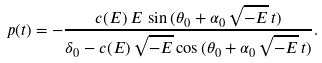Convert formula to latex. <formula><loc_0><loc_0><loc_500><loc_500>p ( t ) = - \frac { c ( E ) \, E \, \sin { ( \theta _ { 0 } + \alpha _ { 0 } \, \sqrt { - E } \, t ) } } { \delta _ { 0 } - c ( E ) \, \sqrt { - E } \cos { ( \theta _ { 0 } + \alpha _ { 0 } \, \sqrt { - E } \, t ) } } .</formula> 